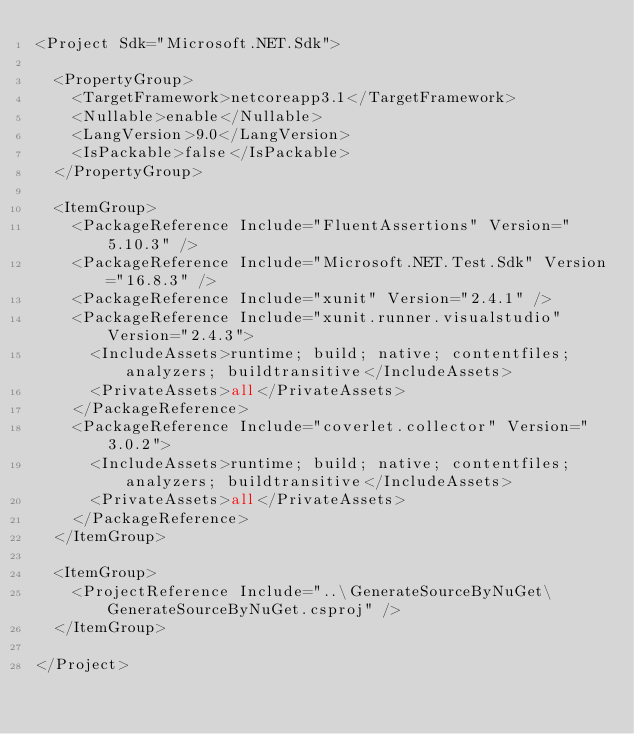Convert code to text. <code><loc_0><loc_0><loc_500><loc_500><_XML_><Project Sdk="Microsoft.NET.Sdk">

  <PropertyGroup>
    <TargetFramework>netcoreapp3.1</TargetFramework>
    <Nullable>enable</Nullable>
    <LangVersion>9.0</LangVersion>
    <IsPackable>false</IsPackable>
  </PropertyGroup>

  <ItemGroup>
    <PackageReference Include="FluentAssertions" Version="5.10.3" />
    <PackageReference Include="Microsoft.NET.Test.Sdk" Version="16.8.3" />
    <PackageReference Include="xunit" Version="2.4.1" />
    <PackageReference Include="xunit.runner.visualstudio" Version="2.4.3">
      <IncludeAssets>runtime; build; native; contentfiles; analyzers; buildtransitive</IncludeAssets>
      <PrivateAssets>all</PrivateAssets>
    </PackageReference>
    <PackageReference Include="coverlet.collector" Version="3.0.2">
      <IncludeAssets>runtime; build; native; contentfiles; analyzers; buildtransitive</IncludeAssets>
      <PrivateAssets>all</PrivateAssets>
    </PackageReference>
  </ItemGroup>

  <ItemGroup>
    <ProjectReference Include="..\GenerateSourceByNuGet\GenerateSourceByNuGet.csproj" />
  </ItemGroup>

</Project></code> 